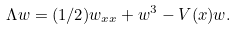<formula> <loc_0><loc_0><loc_500><loc_500>\Lambda w = ( 1 / 2 ) w _ { x x } + w ^ { 3 } - V ( x ) w .</formula> 